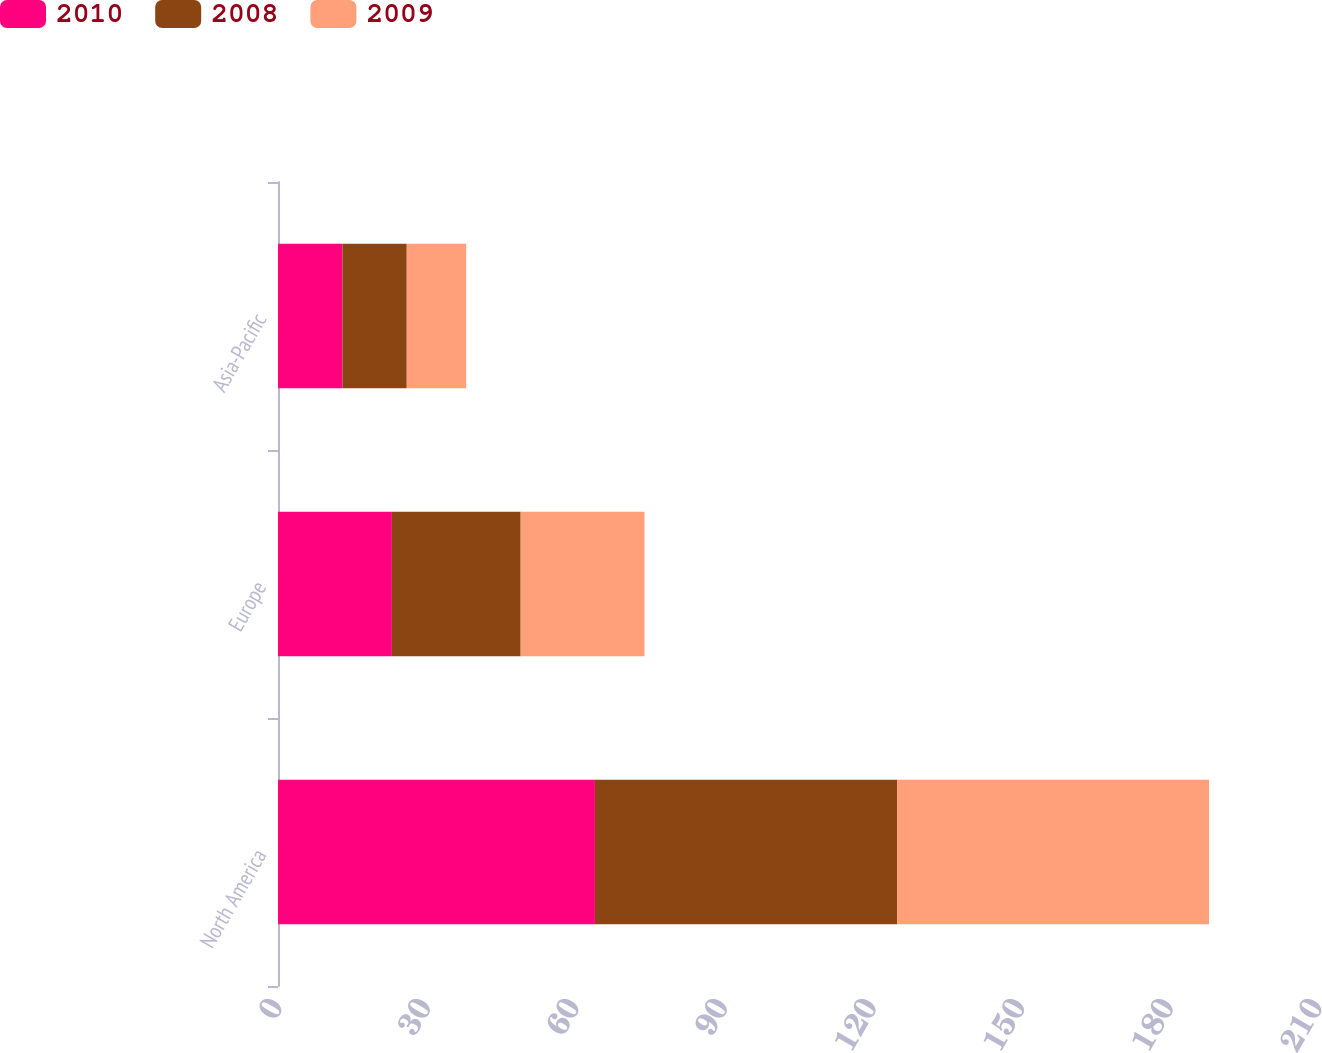Convert chart. <chart><loc_0><loc_0><loc_500><loc_500><stacked_bar_chart><ecel><fcel>North America<fcel>Europe<fcel>Asia-Pacific<nl><fcel>2010<fcel>64<fcel>23<fcel>13<nl><fcel>2008<fcel>61<fcel>26<fcel>13<nl><fcel>2009<fcel>63<fcel>25<fcel>12<nl></chart> 